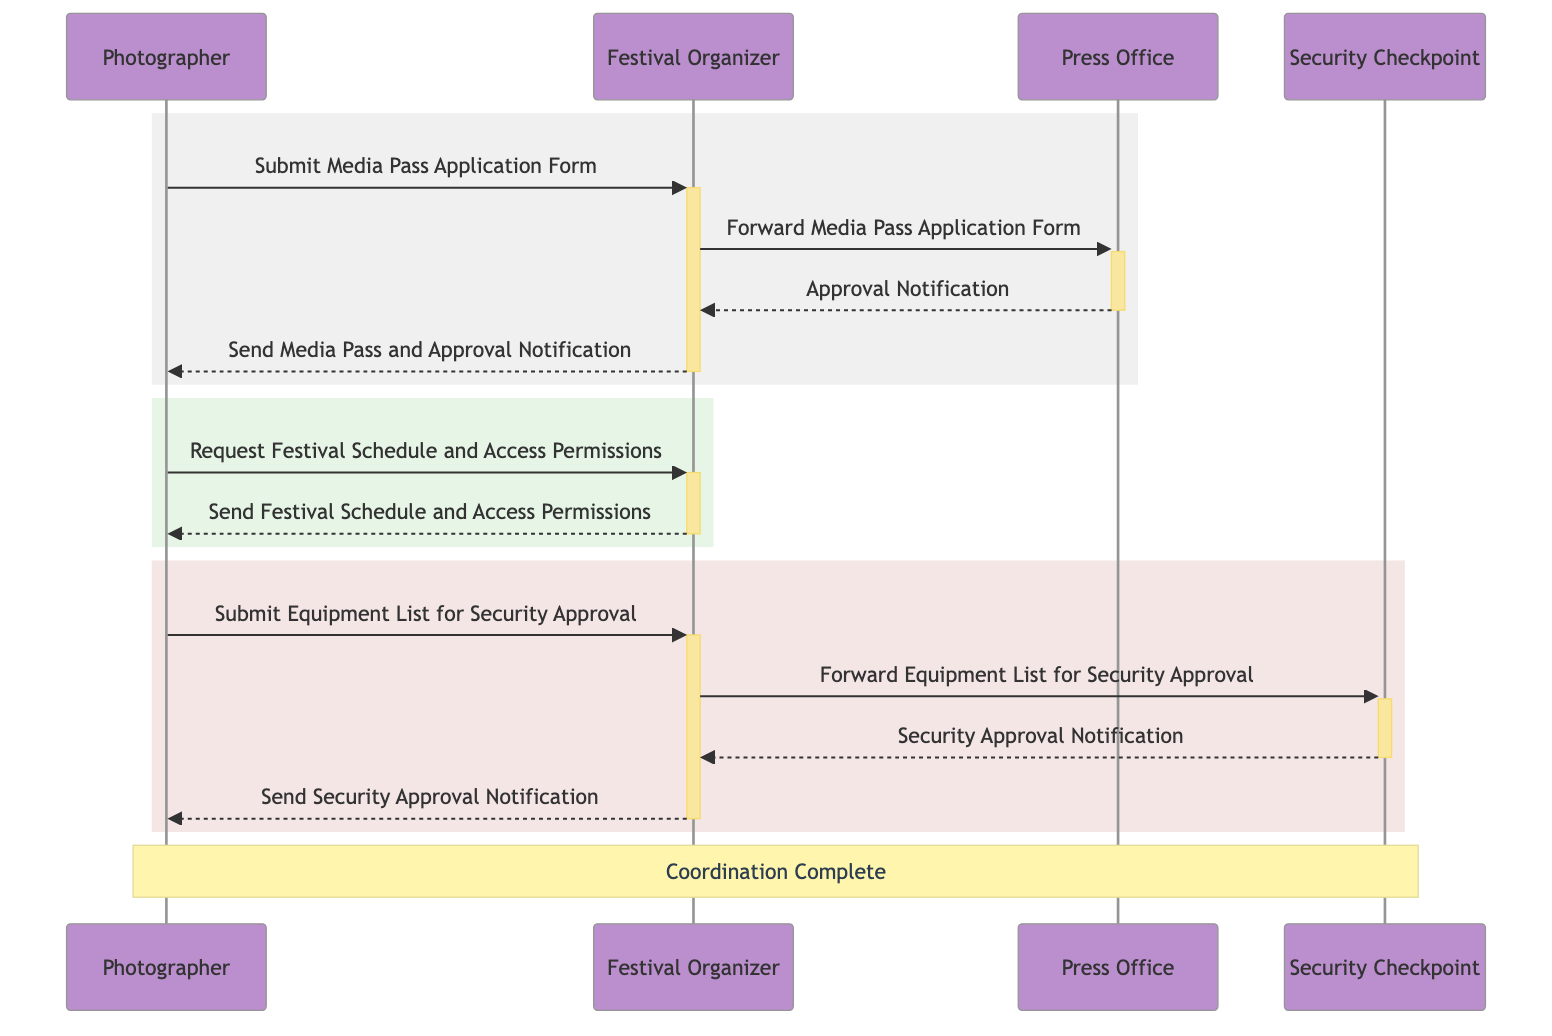What is the first action taken by the Photographer? The first action taken by the Photographer is to submit the Media Pass Application Form to the Festival Organizer. This is indicated as the first arrow pointing from Photographer to Festival Organizer in the diagram.
Answer: Submit Media Pass Application Form Who does the Festival Organizer forward the Media Pass Application Form to? The Festival Organizer forwards the Media Pass Application Form to the Press Office as shown by the arrow from Festival Organizer to Press Office in the diagram.
Answer: Press Office How many notifications does the Festival Organizer send to the Photographer? The Festival Organizer sends two notifications to the Photographer: the Media Pass and Approval Notification and the Security Approval Notification. The diagram tracks both instances with arrows pointing from Festival Organizer to Photographer.
Answer: 2 What document does the Photographer submit for Security Approval? The Photographer submits the Equipment List for Security Approval, as indicated by the arrow pointing from Photographer to Festival Organizer labeled 'Submit Equipment List for Security Approval.'
Answer: Equipment List From which actor does the Approval Notification originate? The Approval Notification originates from the Press Office. This is evident from the arrow going from Press Office to Festival Organizer labeled 'Approval Notification.'
Answer: Press Office What is the last action in the sequence for the Photographer? The last action in the sequence for the Photographer is receiving the Security Approval Notification from the Festival Organizer, which follows the completion of the Security Checkpoint approval process. This is the final arrow directed from Festival Organizer to Photographer.
Answer: Send Security Approval Notification How many actors are involved in this sequence diagram? The sequence diagram involves four actors: Photographer, Festival Organizer, Press Office, and Security Checkpoint. These are explicitly listed at the beginning of the diagram's structure.
Answer: 4 What does the Security Checkpoint send to the Festival Organizer? The Security Checkpoint sends a Security Approval Notification to the Festival Organizer, evidenced by the arrow pointing from Security Checkpoint to Festival Organizer in the diagram.
Answer: Security Approval Notification What is the purpose of the rectangle sections in the diagram? The rectangle sections in the diagram delineate different phases of communication between the Photographer and the Festival Organizer, signifying the encapsulated set of actions related to each stage of the media pass coordination process.
Answer: Different phases of communication 